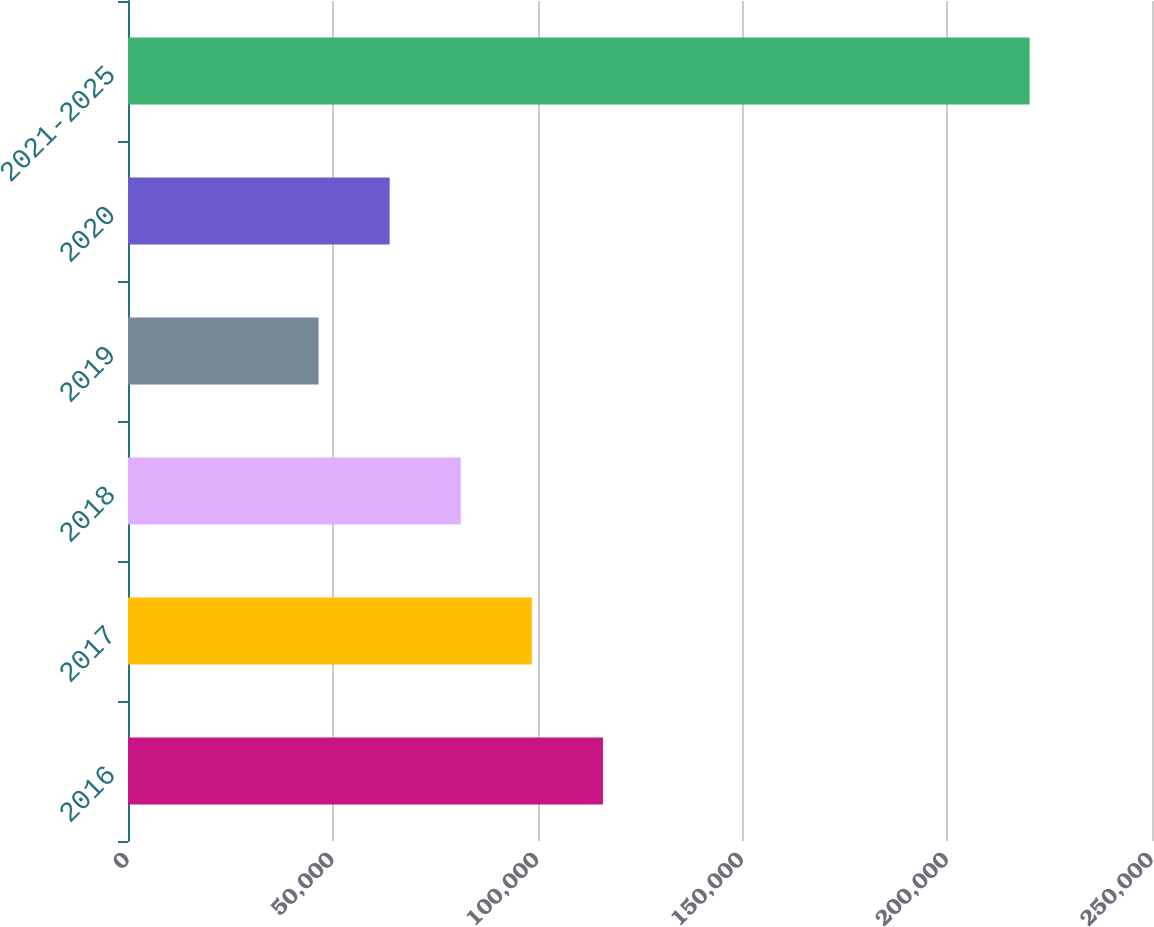<chart> <loc_0><loc_0><loc_500><loc_500><bar_chart><fcel>2016<fcel>2017<fcel>2018<fcel>2019<fcel>2020<fcel>2021-2025<nl><fcel>115962<fcel>98602<fcel>81242<fcel>46522<fcel>63882<fcel>220122<nl></chart> 